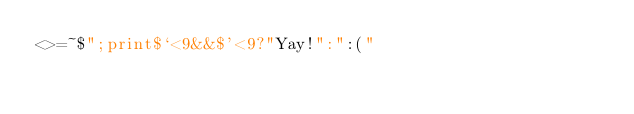Convert code to text. <code><loc_0><loc_0><loc_500><loc_500><_Perl_><>=~$";print$`<9&&$'<9?"Yay!":":("</code> 